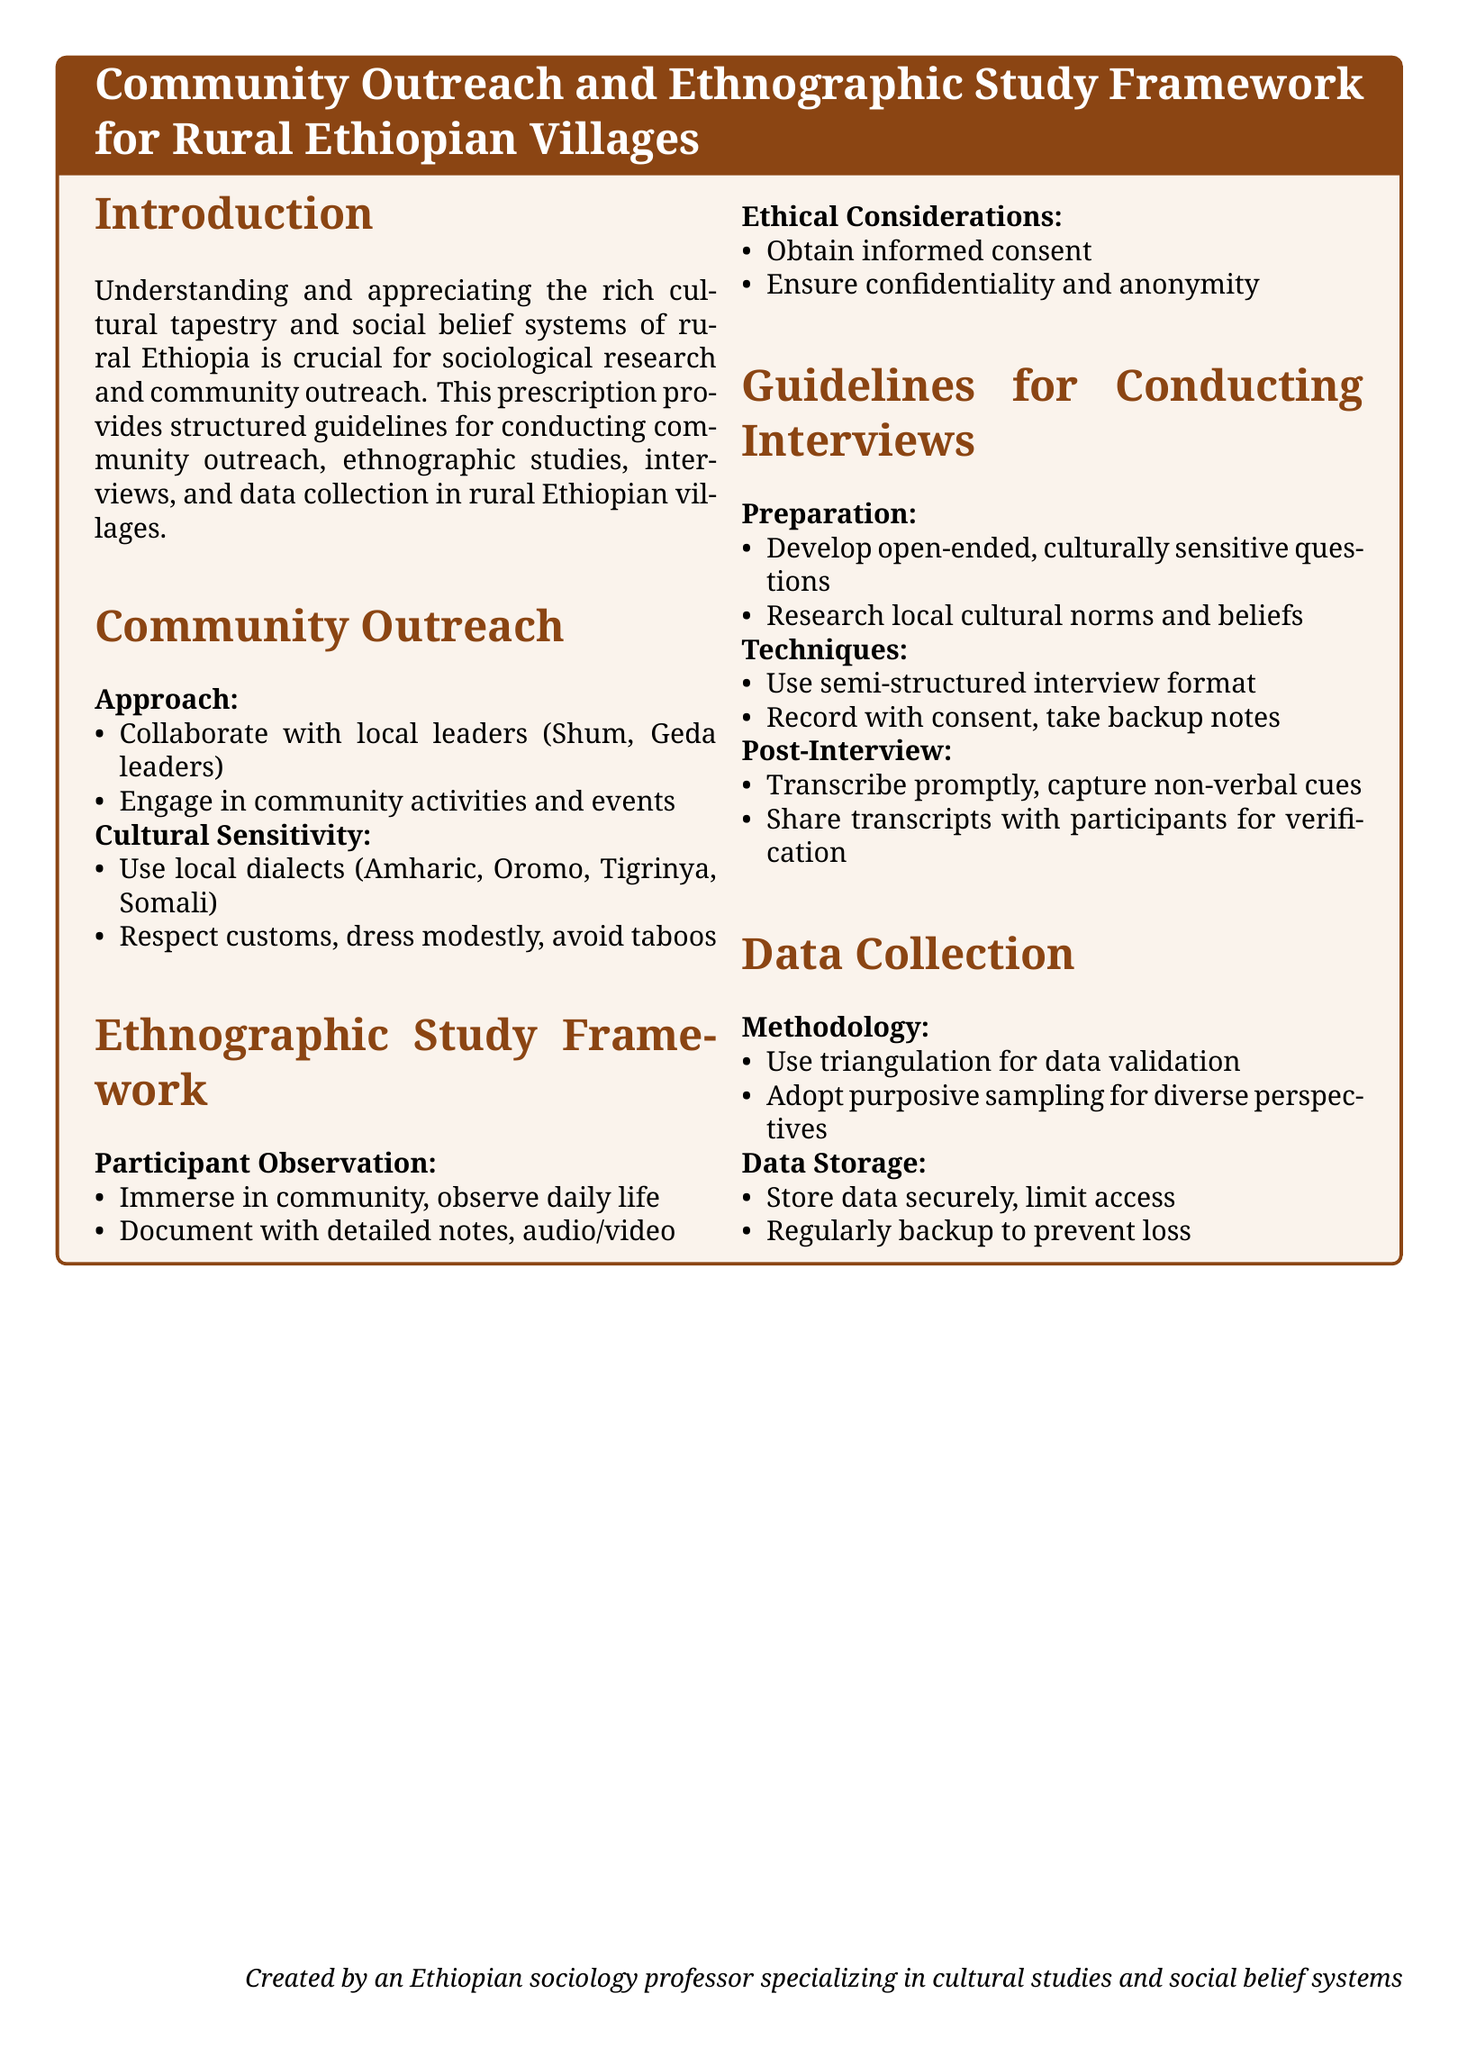what is the title of the document? The title is prominently displayed in the tcolorbox at the beginning of the document.
Answer: Community Outreach and Ethnographic Study Framework for Rural Ethiopian Villages which dialects are suggested for use in community outreach? The document specifies local dialects to use for cultural sensitivity purposes.
Answer: Amharic, Oromo, Tigrinya, Somali what is the first step in the participant observation guideline? This information is found under the Participant Observation section of the ethnographic study framework.
Answer: Immerse in community, observe daily life what type of interview format is recommended? This is mentioned in the Guidelines for Conducting Interviews section regarding techniques.
Answer: Semi-structured interview format what should be obtained from participants to ensure ethical considerations? This is outlined as a critical aspect of the Ethical Considerations section.
Answer: Informed consent what is the purpose of triangulation in data collection? This purpose is explained under the Methodology subsection of the Data Collection section.
Answer: Data validation how should collected data be stored according to the document? This information is found in the Data Storage subsection of the Data Collection section.
Answer: Store data securely, limit access what is suggested to document during participant observations? This information is found under the Participant Observation section regarding documentation methods.
Answer: Detailed notes, audio/video how soon should interviews be transcribed post-interview? This is specified in the Post-Interview section of the Guidelines for Conducting Interviews.
Answer: Promptly 